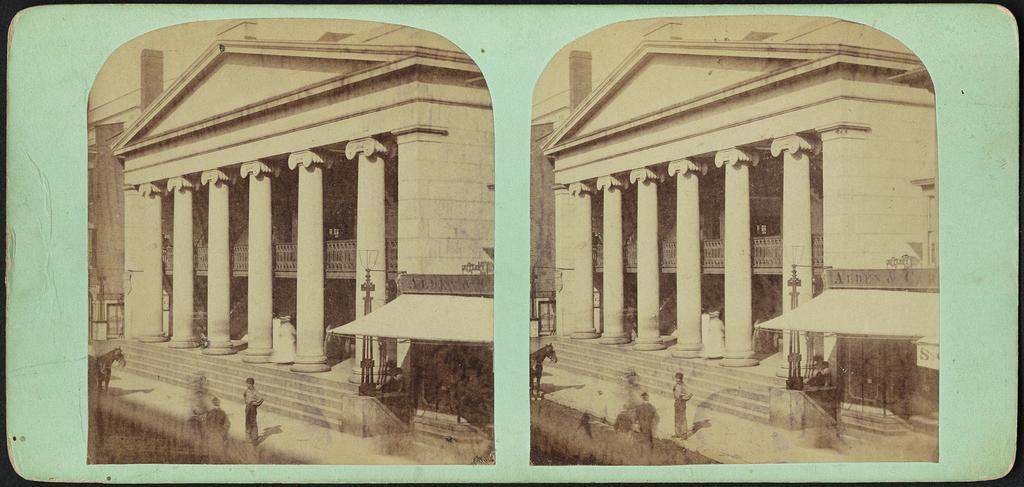What type of artwork is the image? The image is a collage. Can you describe the subjects in the image? There are persons, a horse, buildings, and a tent in the image. What type of egg is being used as a territory marker in the image? There is no egg present in the image, and therefore no territory markers can be observed. 